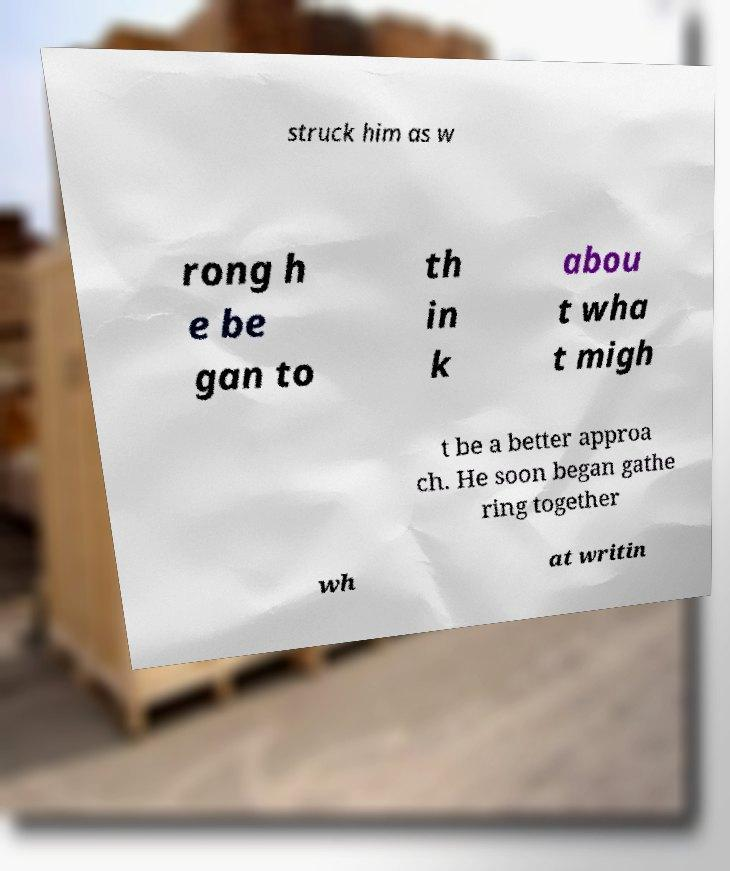Please read and relay the text visible in this image. What does it say? struck him as w rong h e be gan to th in k abou t wha t migh t be a better approa ch. He soon began gathe ring together wh at writin 